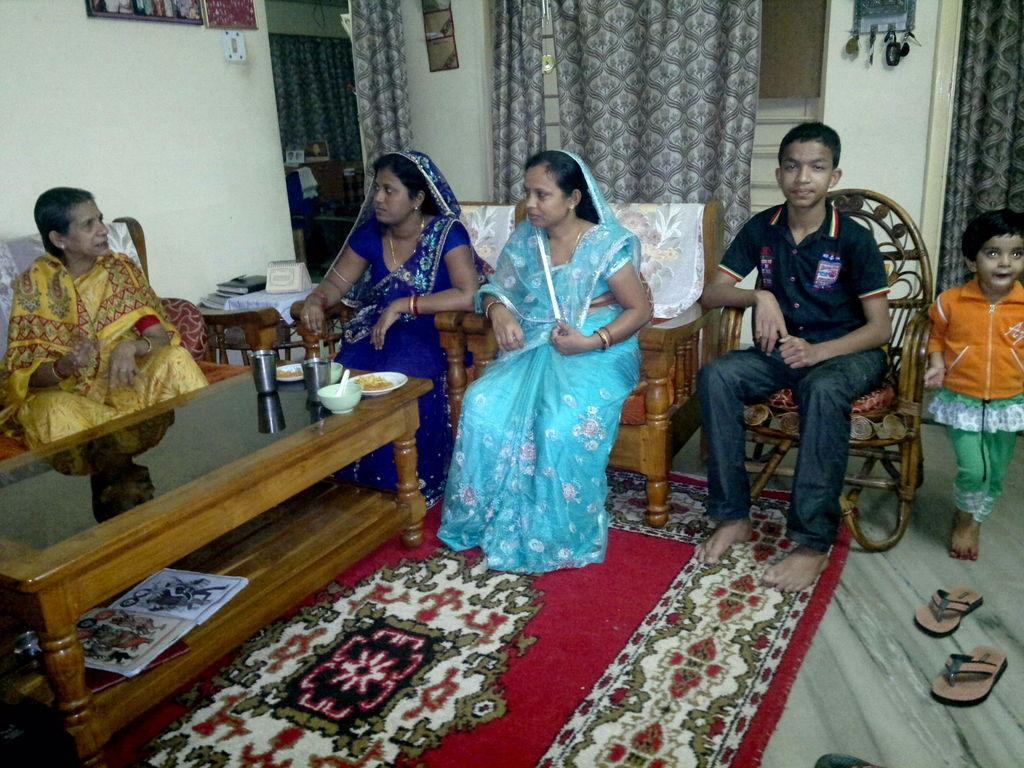What are the people in the image doing? The people in the image are seated on chairs. What objects are on the table in the image? There are glasses and plates on the table. What type of window treatment is visible in the image? There are curtains near a window in the image. What is the girl in the image doing? The girl is standing in the image. What type of screw can be seen on the calendar in the image? There is no screw or calendar present in the image. 